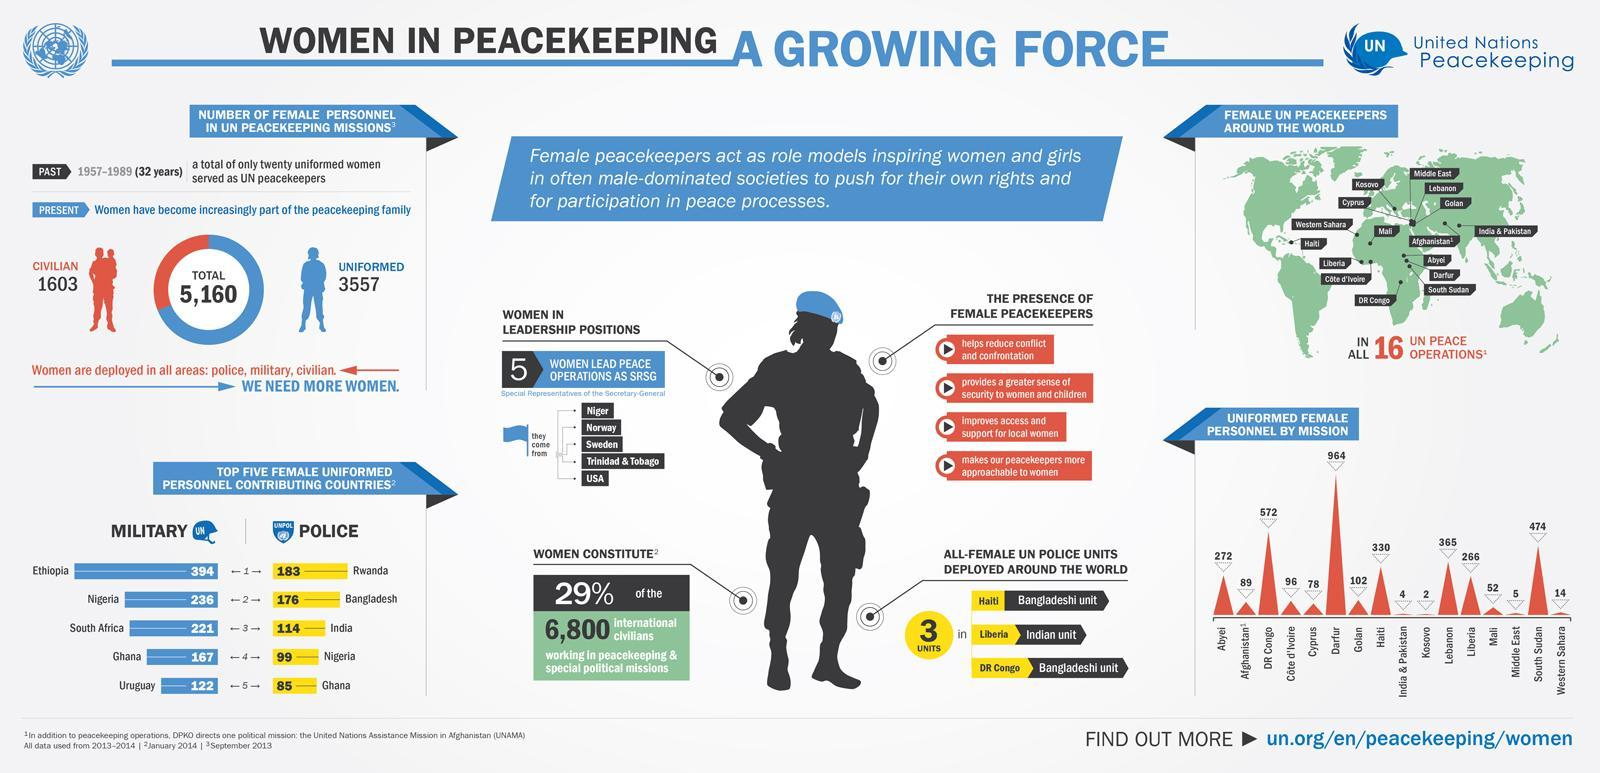Around what percent of civilian women is part of peacekeeping family?
Answer the question with a short phrase. 31% Which mission had the highest number of female personnel? Darfur Which country contributes the most women as UN peacekeeping forces? Ethiopia What percent of international civilians in peacekeeping and special political missions are not women? 71% Which mission had the least number of female personnel? Kosovo 